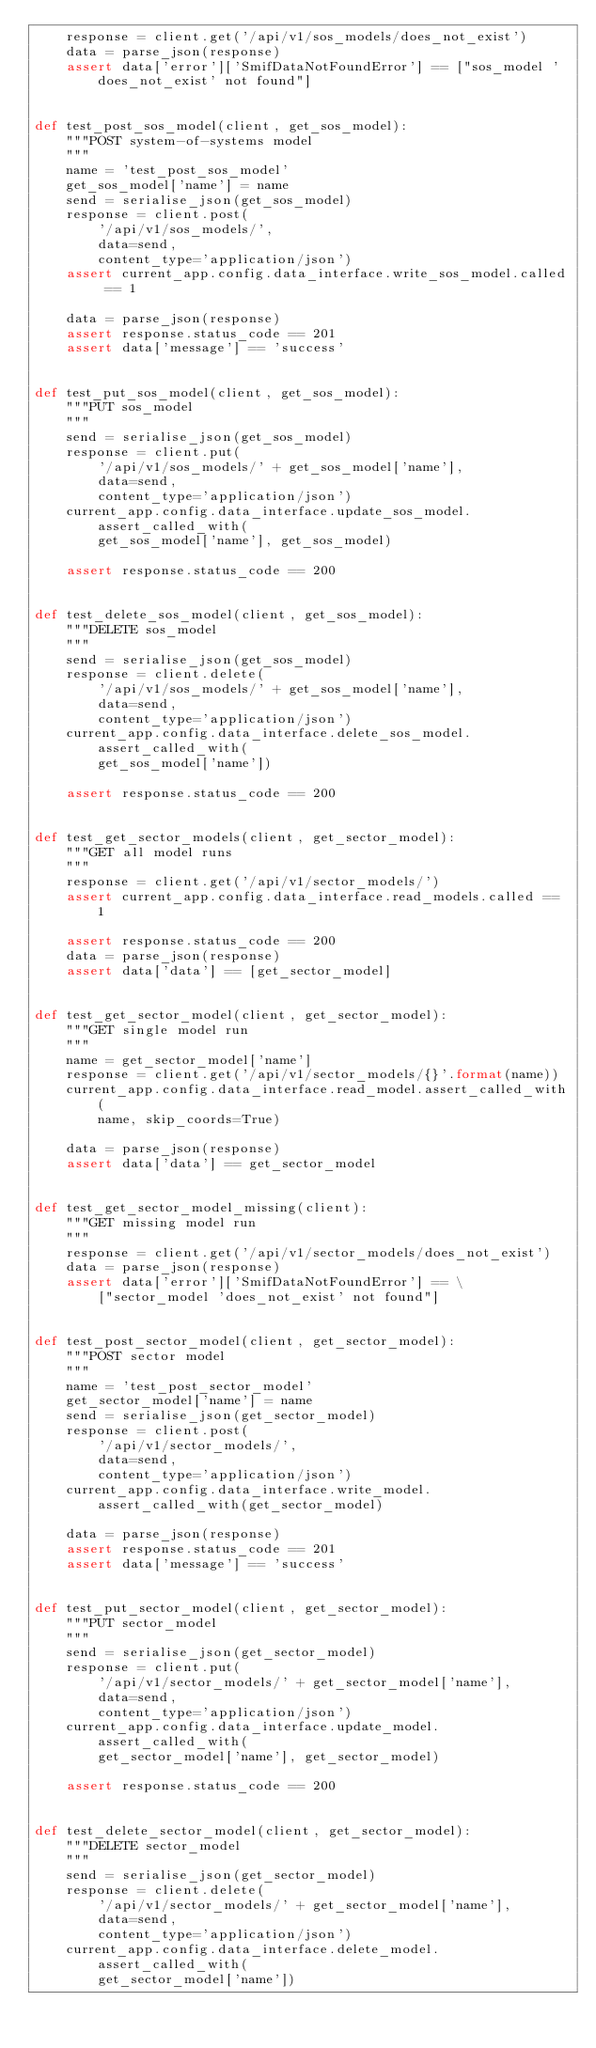Convert code to text. <code><loc_0><loc_0><loc_500><loc_500><_Python_>    response = client.get('/api/v1/sos_models/does_not_exist')
    data = parse_json(response)
    assert data['error']['SmifDataNotFoundError'] == ["sos_model 'does_not_exist' not found"]


def test_post_sos_model(client, get_sos_model):
    """POST system-of-systems model
    """
    name = 'test_post_sos_model'
    get_sos_model['name'] = name
    send = serialise_json(get_sos_model)
    response = client.post(
        '/api/v1/sos_models/',
        data=send,
        content_type='application/json')
    assert current_app.config.data_interface.write_sos_model.called == 1

    data = parse_json(response)
    assert response.status_code == 201
    assert data['message'] == 'success'


def test_put_sos_model(client, get_sos_model):
    """PUT sos_model
    """
    send = serialise_json(get_sos_model)
    response = client.put(
        '/api/v1/sos_models/' + get_sos_model['name'],
        data=send,
        content_type='application/json')
    current_app.config.data_interface.update_sos_model.assert_called_with(
        get_sos_model['name'], get_sos_model)

    assert response.status_code == 200


def test_delete_sos_model(client, get_sos_model):
    """DELETE sos_model
    """
    send = serialise_json(get_sos_model)
    response = client.delete(
        '/api/v1/sos_models/' + get_sos_model['name'],
        data=send,
        content_type='application/json')
    current_app.config.data_interface.delete_sos_model.assert_called_with(
        get_sos_model['name'])

    assert response.status_code == 200


def test_get_sector_models(client, get_sector_model):
    """GET all model runs
    """
    response = client.get('/api/v1/sector_models/')
    assert current_app.config.data_interface.read_models.called == 1

    assert response.status_code == 200
    data = parse_json(response)
    assert data['data'] == [get_sector_model]


def test_get_sector_model(client, get_sector_model):
    """GET single model run
    """
    name = get_sector_model['name']
    response = client.get('/api/v1/sector_models/{}'.format(name))
    current_app.config.data_interface.read_model.assert_called_with(
        name, skip_coords=True)

    data = parse_json(response)
    assert data['data'] == get_sector_model


def test_get_sector_model_missing(client):
    """GET missing model run
    """
    response = client.get('/api/v1/sector_models/does_not_exist')
    data = parse_json(response)
    assert data['error']['SmifDataNotFoundError'] == \
        ["sector_model 'does_not_exist' not found"]


def test_post_sector_model(client, get_sector_model):
    """POST sector model
    """
    name = 'test_post_sector_model'
    get_sector_model['name'] = name
    send = serialise_json(get_sector_model)
    response = client.post(
        '/api/v1/sector_models/',
        data=send,
        content_type='application/json')
    current_app.config.data_interface.write_model.assert_called_with(get_sector_model)

    data = parse_json(response)
    assert response.status_code == 201
    assert data['message'] == 'success'


def test_put_sector_model(client, get_sector_model):
    """PUT sector_model
    """
    send = serialise_json(get_sector_model)
    response = client.put(
        '/api/v1/sector_models/' + get_sector_model['name'],
        data=send,
        content_type='application/json')
    current_app.config.data_interface.update_model.assert_called_with(
        get_sector_model['name'], get_sector_model)

    assert response.status_code == 200


def test_delete_sector_model(client, get_sector_model):
    """DELETE sector_model
    """
    send = serialise_json(get_sector_model)
    response = client.delete(
        '/api/v1/sector_models/' + get_sector_model['name'],
        data=send,
        content_type='application/json')
    current_app.config.data_interface.delete_model.assert_called_with(
        get_sector_model['name'])
</code> 